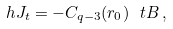<formula> <loc_0><loc_0><loc_500><loc_500>\ h J _ { t } = - C _ { q - 3 } ( r _ { 0 } ) \ t B \, ,</formula> 